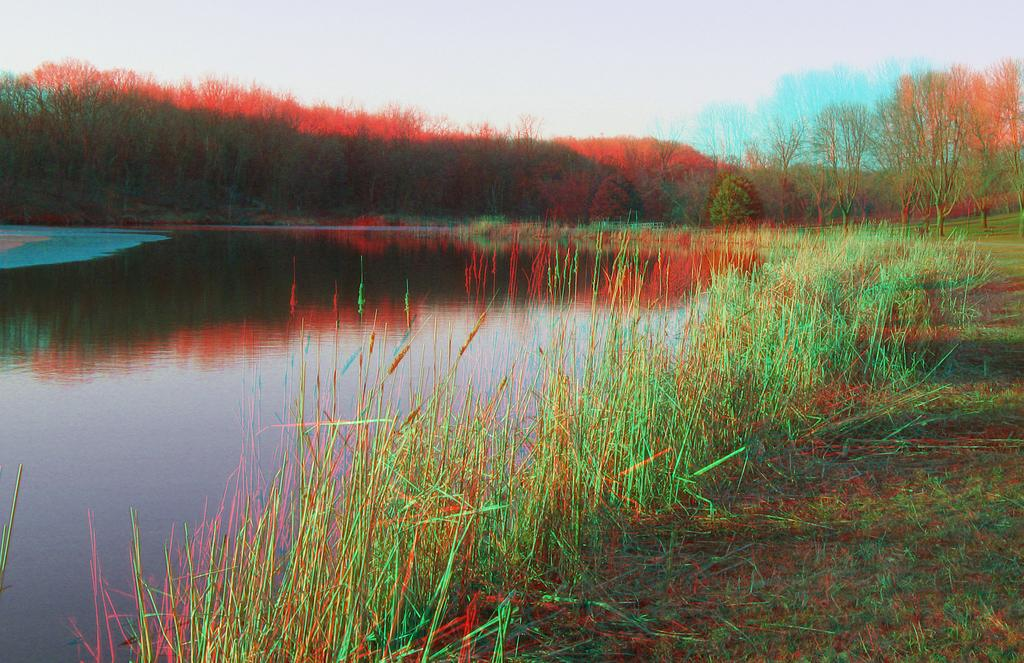What type of landscape is depicted in the image? The image contains a grassland. What type of water feature can be seen in the image? There is a canal in the image. What type of vegetation is present in the image? There are trees in the image. What part of the natural environment is visible in the image? The sky is visible in the image. How many cakes are being carried by the giants in the image? There are no giants or cakes present in the image. 